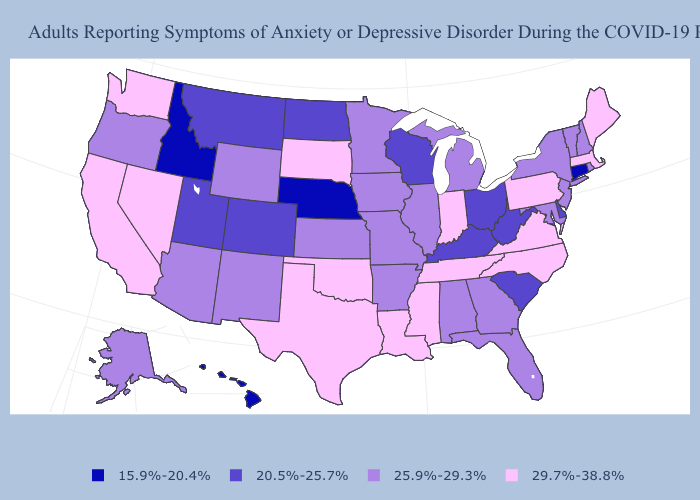Name the states that have a value in the range 20.5%-25.7%?
Answer briefly. Colorado, Delaware, Kentucky, Montana, North Dakota, Ohio, South Carolina, Utah, West Virginia, Wisconsin. Among the states that border Tennessee , does Kentucky have the lowest value?
Write a very short answer. Yes. Does Indiana have the same value as California?
Answer briefly. Yes. How many symbols are there in the legend?
Give a very brief answer. 4. Does Oklahoma have the same value as Indiana?
Concise answer only. Yes. Name the states that have a value in the range 20.5%-25.7%?
Answer briefly. Colorado, Delaware, Kentucky, Montana, North Dakota, Ohio, South Carolina, Utah, West Virginia, Wisconsin. What is the lowest value in states that border Washington?
Be succinct. 15.9%-20.4%. What is the highest value in the USA?
Answer briefly. 29.7%-38.8%. Name the states that have a value in the range 20.5%-25.7%?
Answer briefly. Colorado, Delaware, Kentucky, Montana, North Dakota, Ohio, South Carolina, Utah, West Virginia, Wisconsin. Does Michigan have the highest value in the USA?
Short answer required. No. What is the value of Maryland?
Be succinct. 25.9%-29.3%. Among the states that border South Carolina , does North Carolina have the highest value?
Short answer required. Yes. What is the value of Washington?
Give a very brief answer. 29.7%-38.8%. Which states hav the highest value in the West?
Give a very brief answer. California, Nevada, Washington. Among the states that border Nevada , does Idaho have the lowest value?
Quick response, please. Yes. 